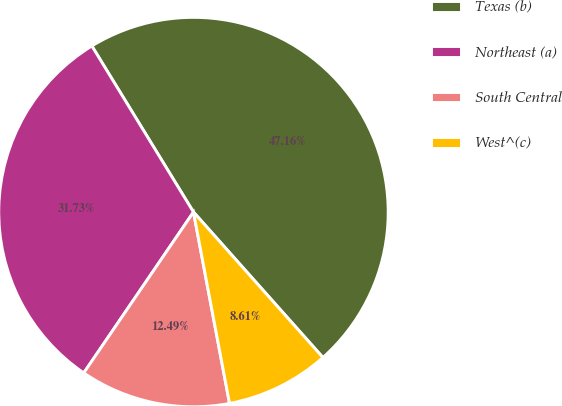Convert chart. <chart><loc_0><loc_0><loc_500><loc_500><pie_chart><fcel>Texas (b)<fcel>Northeast (a)<fcel>South Central<fcel>West^(c)<nl><fcel>47.16%<fcel>31.73%<fcel>12.49%<fcel>8.61%<nl></chart> 